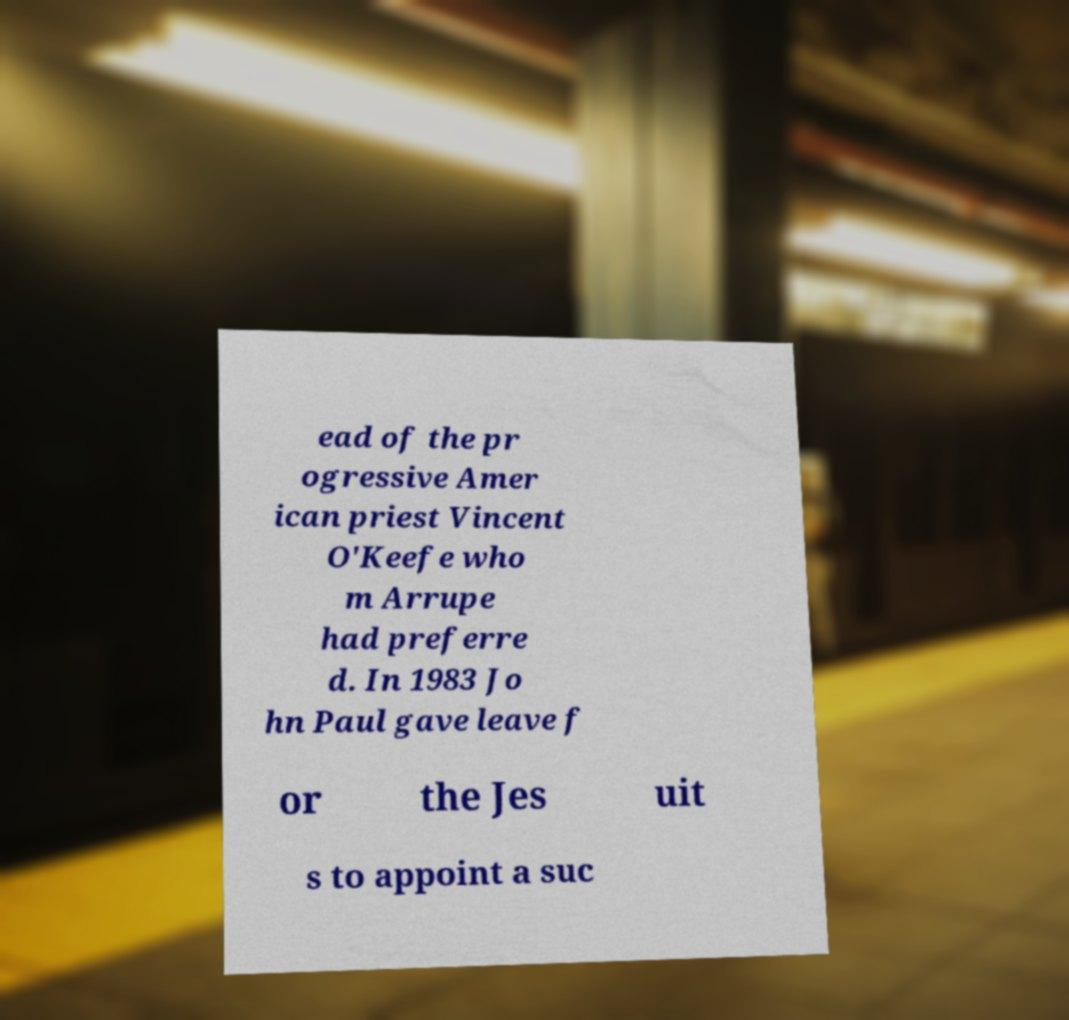Can you read and provide the text displayed in the image?This photo seems to have some interesting text. Can you extract and type it out for me? ead of the pr ogressive Amer ican priest Vincent O'Keefe who m Arrupe had preferre d. In 1983 Jo hn Paul gave leave f or the Jes uit s to appoint a suc 